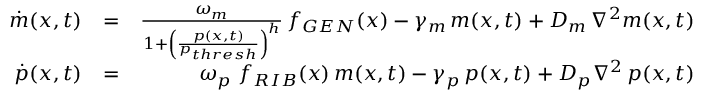Convert formula to latex. <formula><loc_0><loc_0><loc_500><loc_500>\begin{array} { r l r } { \dot { m } ( x , t ) } & { = } & { \frac { \omega _ { m } } { 1 + \left ( \frac { p ( x , t ) } { p _ { t h r e s h } } \right ) ^ { h } } \, f _ { G E N } ( x ) - \gamma _ { m } \, m ( x , t ) + D _ { m } \, \nabla ^ { 2 } m ( x , t ) } \\ { \dot { p } ( x , t ) } & { = } & { \omega _ { p } \, f _ { R I B } ( x ) \, m ( x , t ) - \gamma _ { p } \, p ( x , t ) + D _ { p } \nabla ^ { 2 } \, p ( x , t ) } \end{array}</formula> 